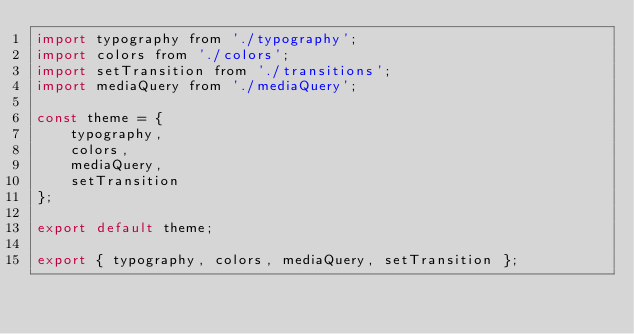<code> <loc_0><loc_0><loc_500><loc_500><_JavaScript_>import typography from './typography';
import colors from './colors';
import setTransition from './transitions';
import mediaQuery from './mediaQuery';

const theme = {
	typography,
	colors,
	mediaQuery,
	setTransition
};

export default theme;

export { typography, colors, mediaQuery, setTransition };
</code> 